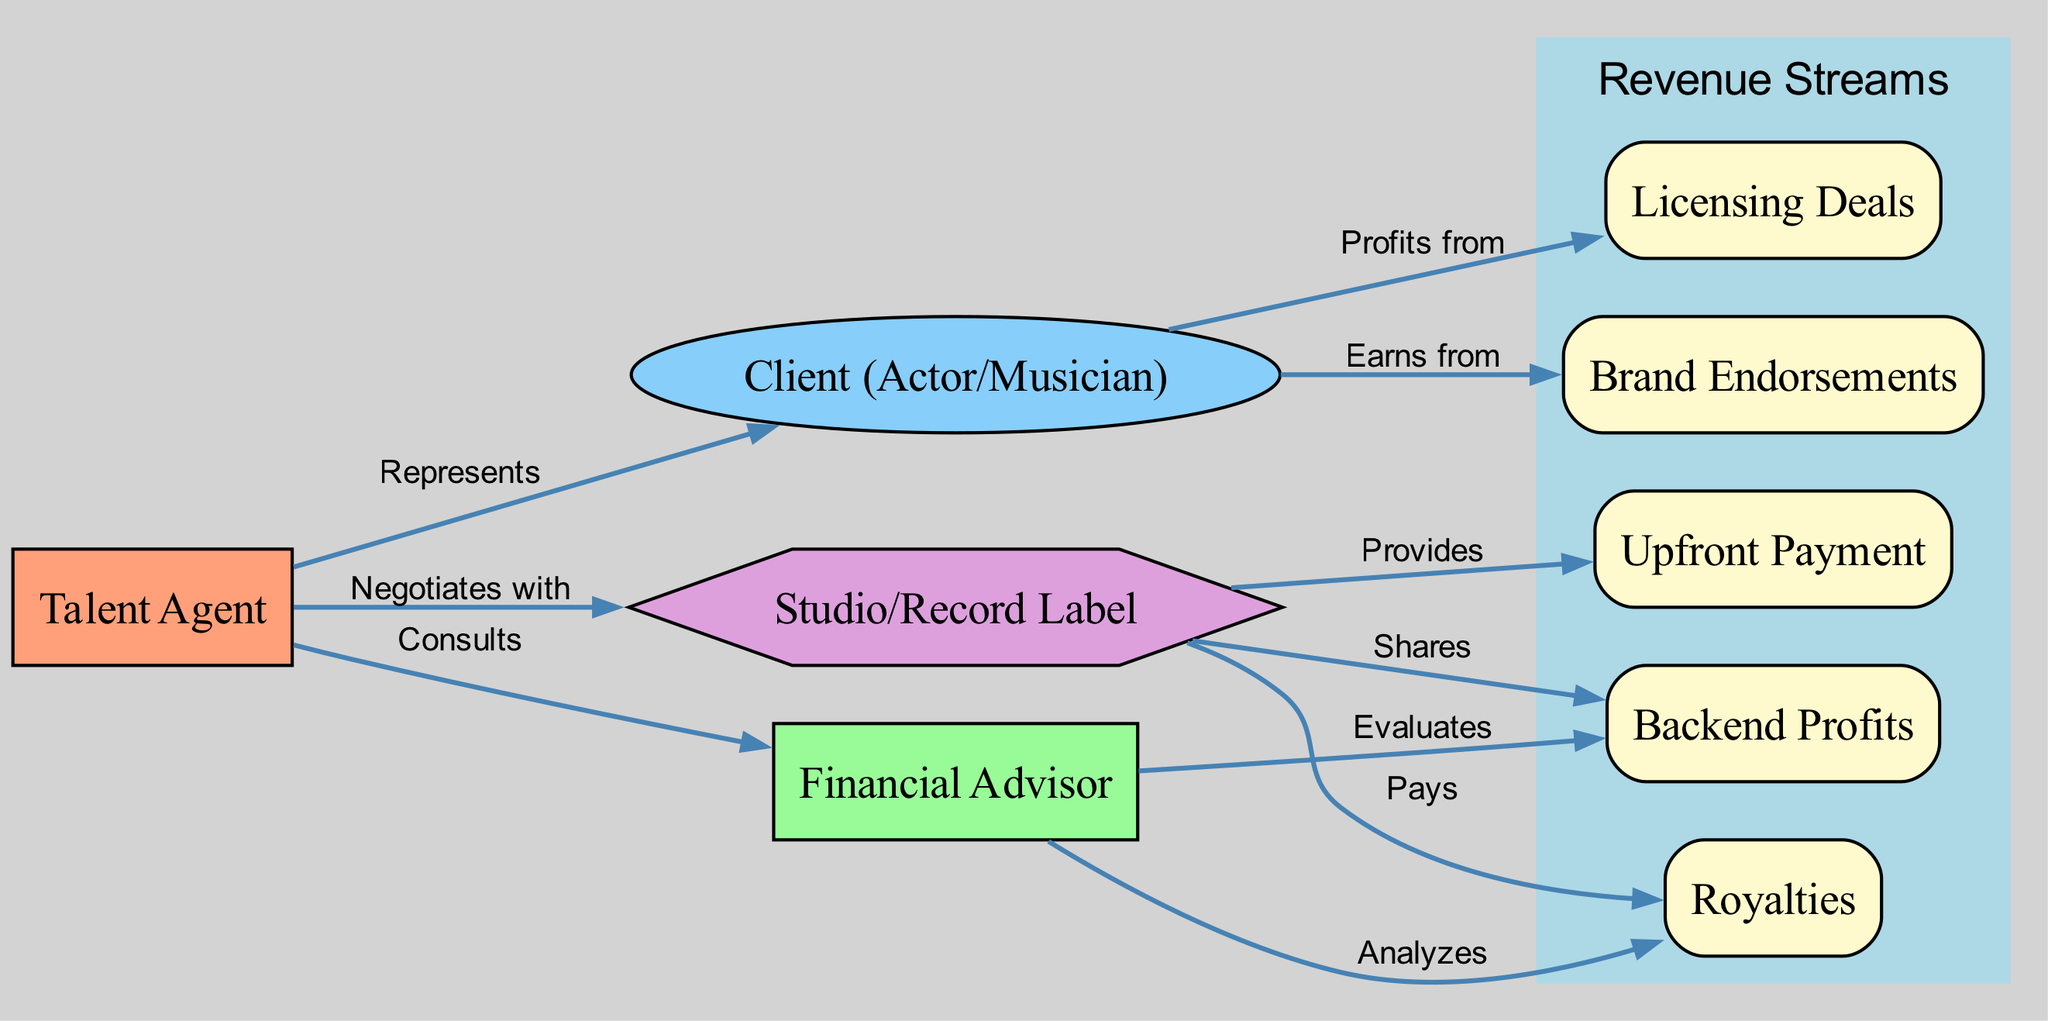What is the role of the talent agent in relation to the client? The talent agent's role in relation to the client is to represent the client, meaning they advocate for the client's interests and work to secure contracts and opportunities on their behalf. This is denoted by the edge labeled "Represents" from the agent node to the client node.
Answer: Represents How many revenue streams are illustrated in the diagram? The diagram lists five distinctive revenue streams: upfront payment, royalties, backend profits, brand endorsements, and licensing deals. This can be counted by referencing the nodes associated with revenue streams.
Answer: Five Who provides upfront payment? The studio or record label is the entity that provides upfront payment to the client. This is indicated by the edge labeled "Provides" that connects the studio node to the upfront payment node.
Answer: Studio What does the financial advisor analyze? The financial advisor analyzes royalties as shown by the edge labeled "Analyzes" that connects the advisor node to the royalties node. This indicates their role in examining the revenue generated through royalties for the client.
Answer: Royalties Which two entities are involved in backend profits? The two entities involved in backend profits are the studio and the financial advisor. The studio shares backend profits with the client as indicated by the edge labeled "Shares," and the advisor evaluates these backend profits, shown by the edge labeled "Evaluates." Thus, both the studio and the advisor play a role in backend profits.
Answer: Studio and Financial Advisor How does the client profit from endorsements? The client profits from endorsements through the relationship denoted in the diagram, where the client earns from brand endorsements as indicated by the edge labeled "Earns from" leading from the client node to the endorsements node. This shows that endorsements represent a source of revenue for the client.
Answer: Earns from What is the relationship between the talent agent and the financial advisor? The relationship between the talent agent and the financial advisor is one of consultation. The talent agent consults the financial advisor for expertise in financial matters, as indicated by the edge labeled "Consults" from the agent node to the advisor node.
Answer: Consults Which node represents the profits derived from licensing deals? The node that represents the profits derived from licensing deals is the licensing node, which connects from the client node indicating that profits flow from this revenue stream to the client. This is straightforward as it is an explicit labeling in the diagram.
Answer: Licensing What structure is used to represent the studio? The studio is represented using a hexagon shape in the diagram, which distinguishes it from other entities represented by different shapes such as rectangles or ellipses. This is a specific visual cue used in the diagram to depict the studio.
Answer: Hexagon What type of payment does the studio provide? The studio provides an upfront payment, as indicated by the edge labeled "Provides" connecting the studio node to the upfront payment node. This action illustrates one of the primary financial relationships between the studio and the client.
Answer: Upfront Payment 